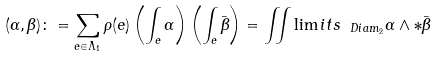Convert formula to latex. <formula><loc_0><loc_0><loc_500><loc_500>( \alpha , \beta ) \colon = \sum _ { e \in \Lambda _ { 1 } } \rho ( e ) \left ( \int _ { e } \alpha \right ) \left ( \int _ { e } \bar { \beta } \right ) = \iint \lim i t s _ { \ D i a m _ { 2 } } \alpha \wedge * \bar { \beta }</formula> 